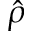Convert formula to latex. <formula><loc_0><loc_0><loc_500><loc_500>\hat { \rho }</formula> 